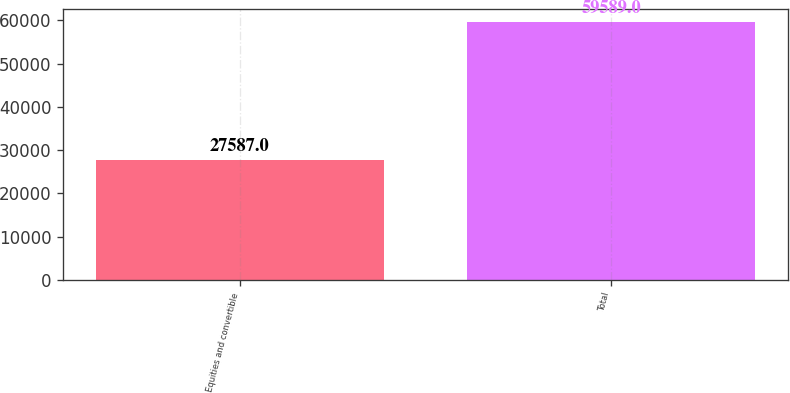Convert chart to OTSL. <chart><loc_0><loc_0><loc_500><loc_500><bar_chart><fcel>Equities and convertible<fcel>Total<nl><fcel>27587<fcel>59589<nl></chart> 